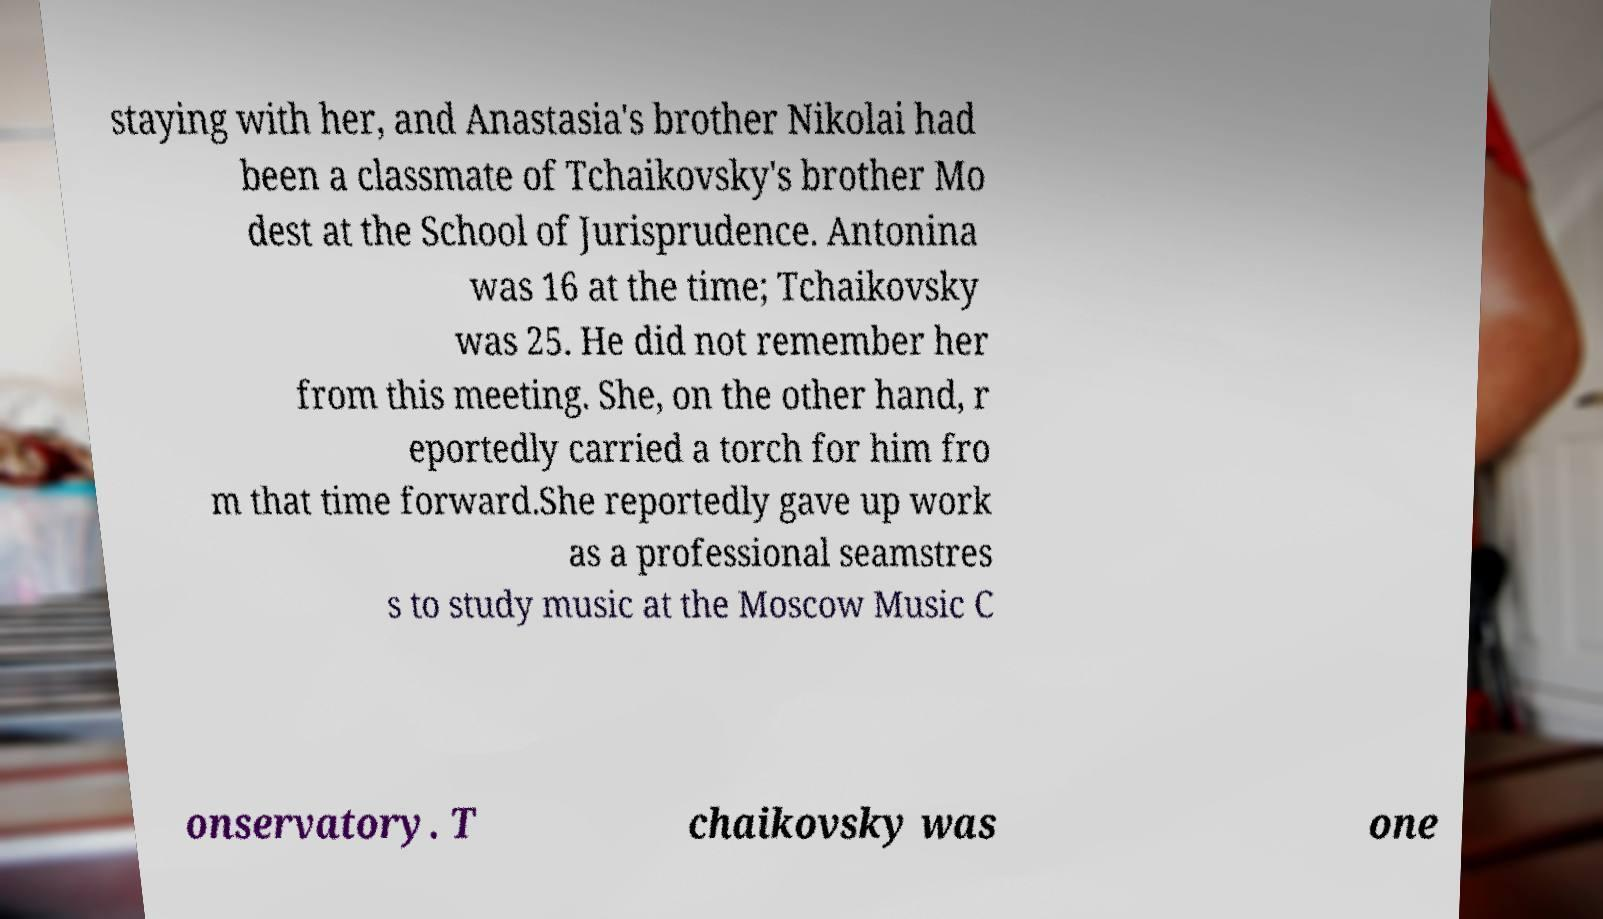Please read and relay the text visible in this image. What does it say? staying with her, and Anastasia's brother Nikolai had been a classmate of Tchaikovsky's brother Mo dest at the School of Jurisprudence. Antonina was 16 at the time; Tchaikovsky was 25. He did not remember her from this meeting. She, on the other hand, r eportedly carried a torch for him fro m that time forward.She reportedly gave up work as a professional seamstres s to study music at the Moscow Music C onservatory. T chaikovsky was one 